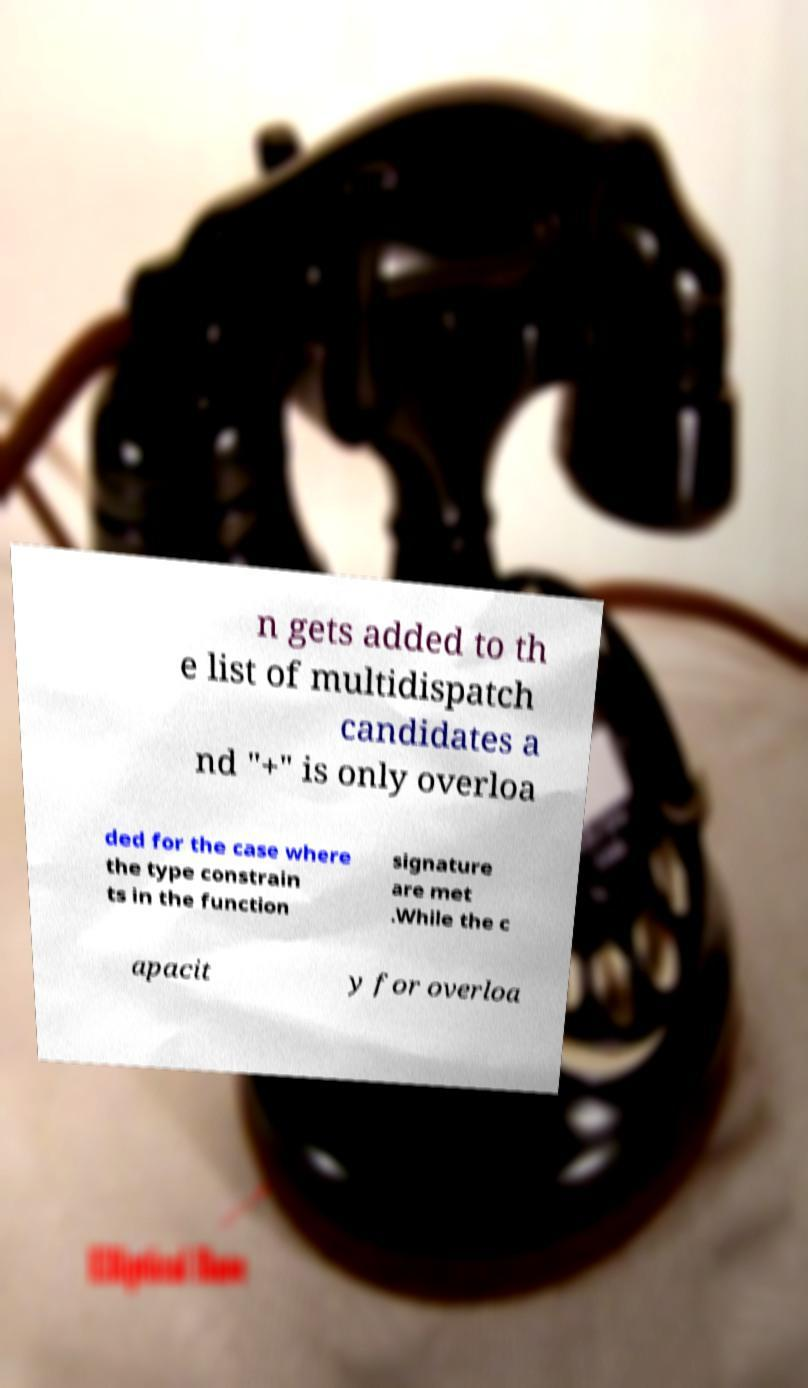What messages or text are displayed in this image? I need them in a readable, typed format. n gets added to th e list of multidispatch candidates a nd "+" is only overloa ded for the case where the type constrain ts in the function signature are met .While the c apacit y for overloa 